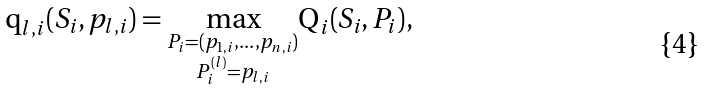<formula> <loc_0><loc_0><loc_500><loc_500>\text {q} _ { l , i } ( S _ { i } , p _ { l , i } ) = \underset { \substack { P _ { i } = ( p _ { 1 , i } , \dots , p _ { n , i } ) \\ P ^ { ( l ) } _ { i } = p _ { l , i } } } { \max } \text {Q} _ { i } ( S _ { i } , P _ { i } ) ,</formula> 